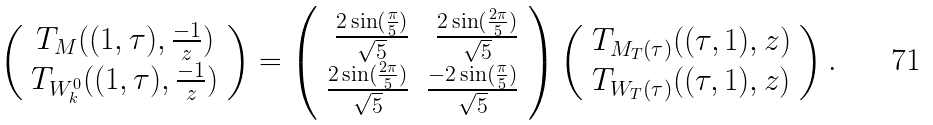Convert formula to latex. <formula><loc_0><loc_0><loc_500><loc_500>\left ( \begin{array} { c } T _ { M } ( ( 1 , \tau ) , \frac { - 1 } { z } ) \\ T _ { W ^ { 0 } _ { k } } ( ( 1 , \tau ) , \frac { - 1 } { z } ) \end{array} \right ) = \left ( \begin{array} { r r } \frac { 2 \sin ( \frac { \pi } { 5 } ) } { \sqrt { 5 } } & \frac { 2 \sin ( \frac { 2 \pi } { 5 } ) } { \sqrt { 5 } } \\ \frac { 2 \sin ( \frac { 2 \pi } { 5 } ) } { \sqrt { 5 } } & \frac { - 2 \sin ( \frac { \pi } { 5 } ) } { \sqrt { 5 } } \end{array} \right ) \left ( \begin{array} { c } T _ { M _ { T } ( \tau ) } ( ( \tau , 1 ) , z ) \\ T _ { W _ { T } ( \tau ) } ( ( \tau , 1 ) , z ) \end{array} \right ) .</formula> 